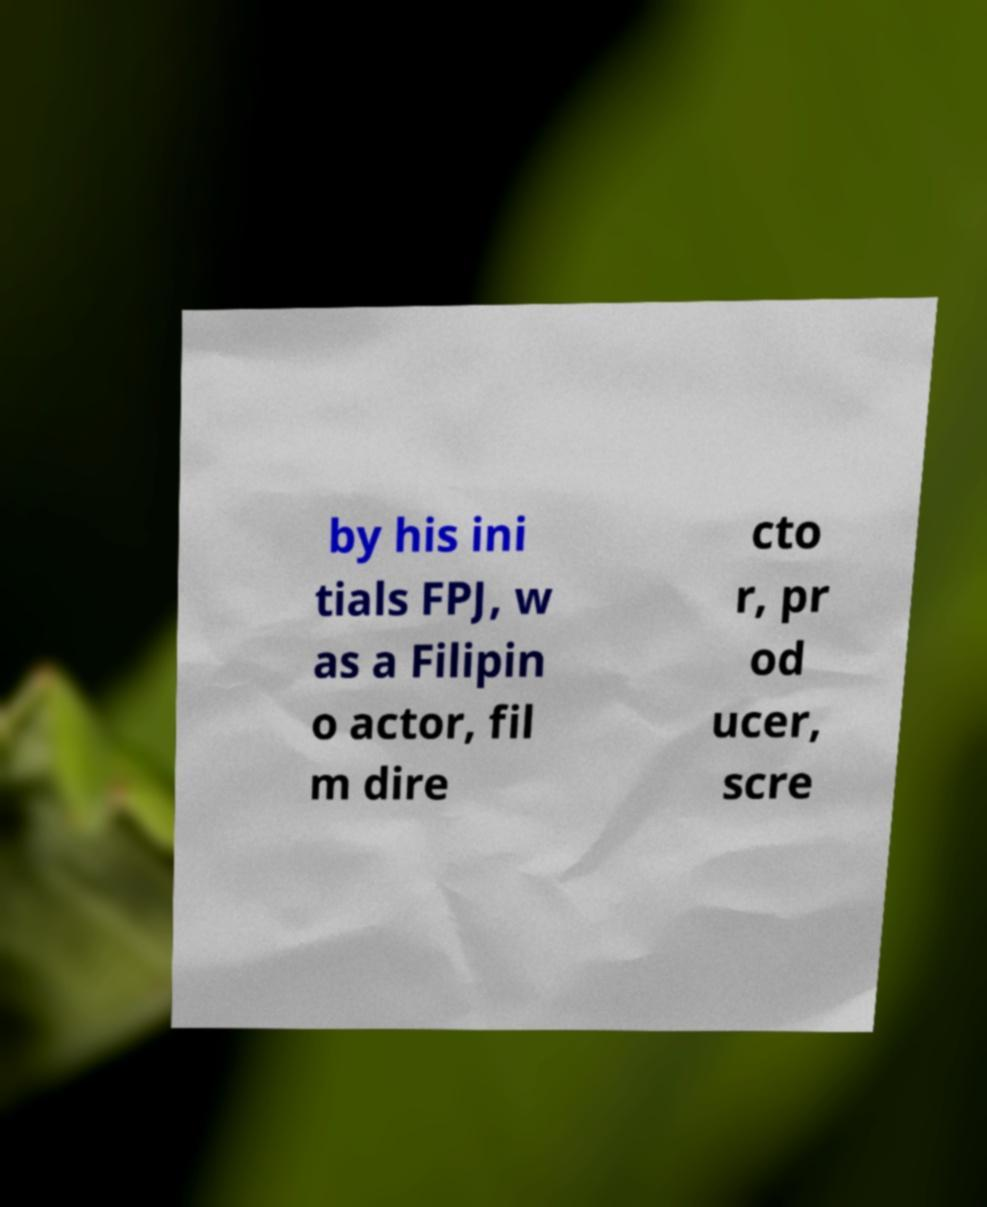Could you assist in decoding the text presented in this image and type it out clearly? by his ini tials FPJ, w as a Filipin o actor, fil m dire cto r, pr od ucer, scre 